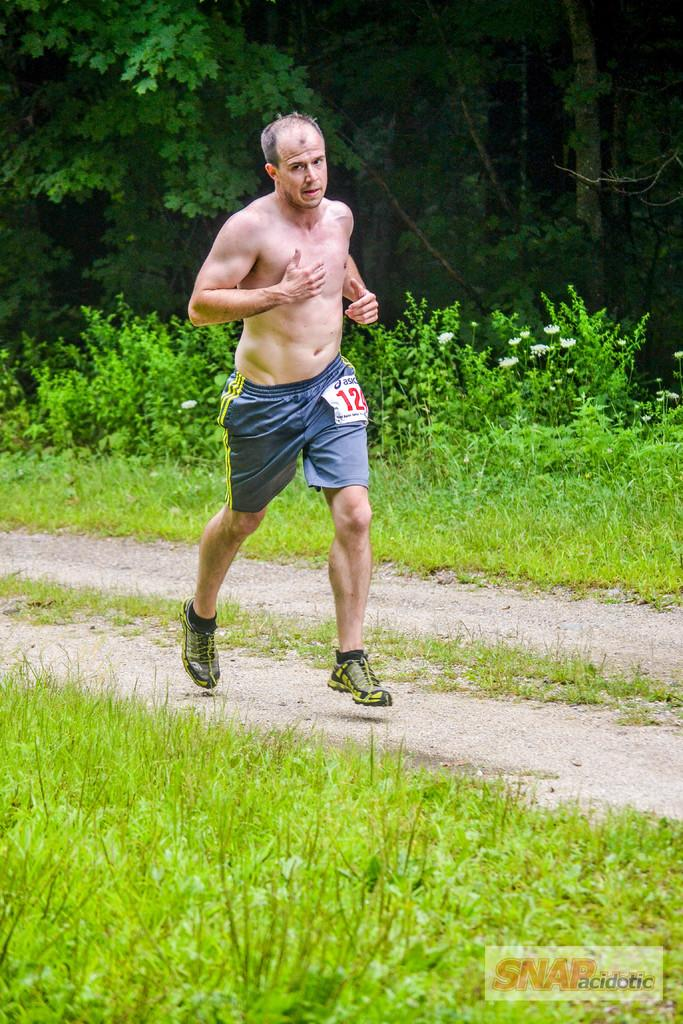<image>
Share a concise interpretation of the image provided. A bare chested name has number 12 on his shorts. 